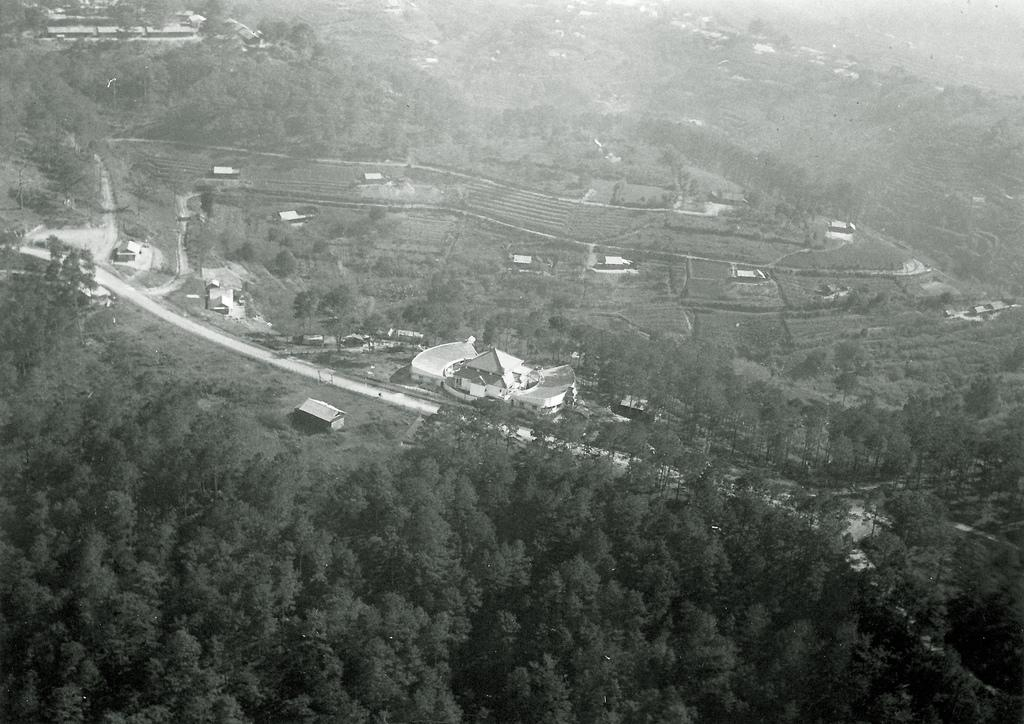What is the main feature in the center of the image? There is a road in the center of the image. What can be seen in the background of the image? There are trees visible in the image. What type of structures are present in the image? There are buildings in the image. How is the image presented in terms of color? The image is black and white in color. What type of paint is the doctor using to conduct a science experiment in the image? There is no doctor or science experiment present in the image; it features a road, trees, and buildings in black and white. 